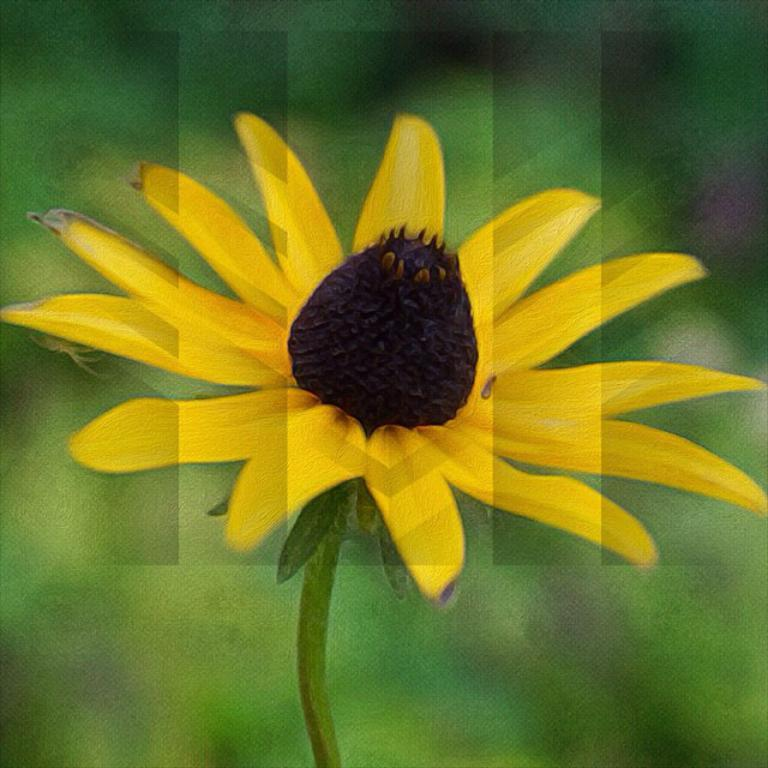What type of flower is present in the image? There is a yellow flower in the image. Can you describe any specific features of the flower? Yes, there is a brown bud on the flower. How would you characterize the background of the image? The background is blurred. What color is the background? The background color is green. How many pies are stacked on top of each other in the image? There are no pies present in the image. What type of rail can be seen in the image? There is no rail present in the image. 